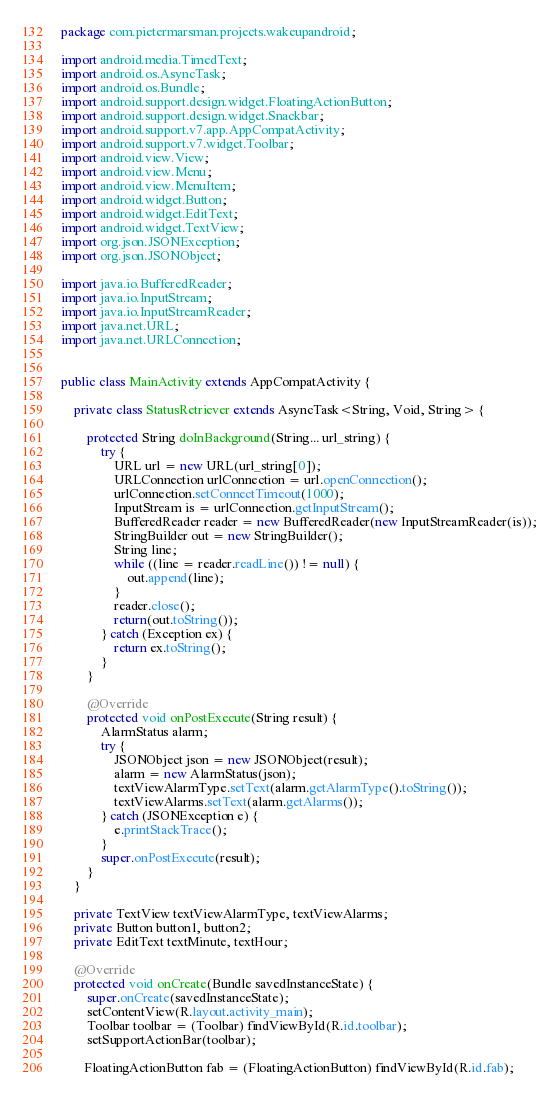<code> <loc_0><loc_0><loc_500><loc_500><_Java_>package com.pietermarsman.projects.wakeupandroid;

import android.media.TimedText;
import android.os.AsyncTask;
import android.os.Bundle;
import android.support.design.widget.FloatingActionButton;
import android.support.design.widget.Snackbar;
import android.support.v7.app.AppCompatActivity;
import android.support.v7.widget.Toolbar;
import android.view.View;
import android.view.Menu;
import android.view.MenuItem;
import android.widget.Button;
import android.widget.EditText;
import android.widget.TextView;
import org.json.JSONException;
import org.json.JSONObject;

import java.io.BufferedReader;
import java.io.InputStream;
import java.io.InputStreamReader;
import java.net.URL;
import java.net.URLConnection;


public class MainActivity extends AppCompatActivity {

    private class StatusRetriever extends AsyncTask<String, Void, String> {

        protected String doInBackground(String... url_string) {
            try {
                URL url = new URL(url_string[0]);
                URLConnection urlConnection = url.openConnection();
                urlConnection.setConnectTimeout(1000);
                InputStream is = urlConnection.getInputStream();
                BufferedReader reader = new BufferedReader(new InputStreamReader(is));
                StringBuilder out = new StringBuilder();
                String line;
                while ((line = reader.readLine()) != null) {
                    out.append(line);
                }
                reader.close();
                return(out.toString());
            } catch (Exception ex) {
                return ex.toString();
            }
        }

        @Override
        protected void onPostExecute(String result) {
            AlarmStatus alarm;
            try {
                JSONObject json = new JSONObject(result);
                alarm = new AlarmStatus(json);
                textViewAlarmType.setText(alarm.getAlarmType().toString());
                textViewAlarms.setText(alarm.getAlarms());
            } catch (JSONException e) {
                e.printStackTrace();
            }
            super.onPostExecute(result);
        }
    }

    private TextView textViewAlarmType, textViewAlarms;
    private Button button1, button2;
    private EditText textMinute, textHour;

    @Override
    protected void onCreate(Bundle savedInstanceState) {
        super.onCreate(savedInstanceState);
        setContentView(R.layout.activity_main);
        Toolbar toolbar = (Toolbar) findViewById(R.id.toolbar);
        setSupportActionBar(toolbar);

       FloatingActionButton fab = (FloatingActionButton) findViewById(R.id.fab);</code> 